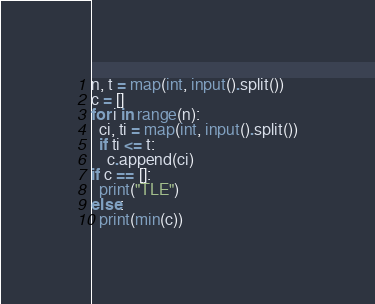Convert code to text. <code><loc_0><loc_0><loc_500><loc_500><_Python_>n, t = map(int, input().split())
c = []
for i in range(n):
  ci, ti = map(int, input().split())
  if ti <= t:
    c.append(ci)
if c == []:
  print("TLE")
else:
  print(min(c))</code> 